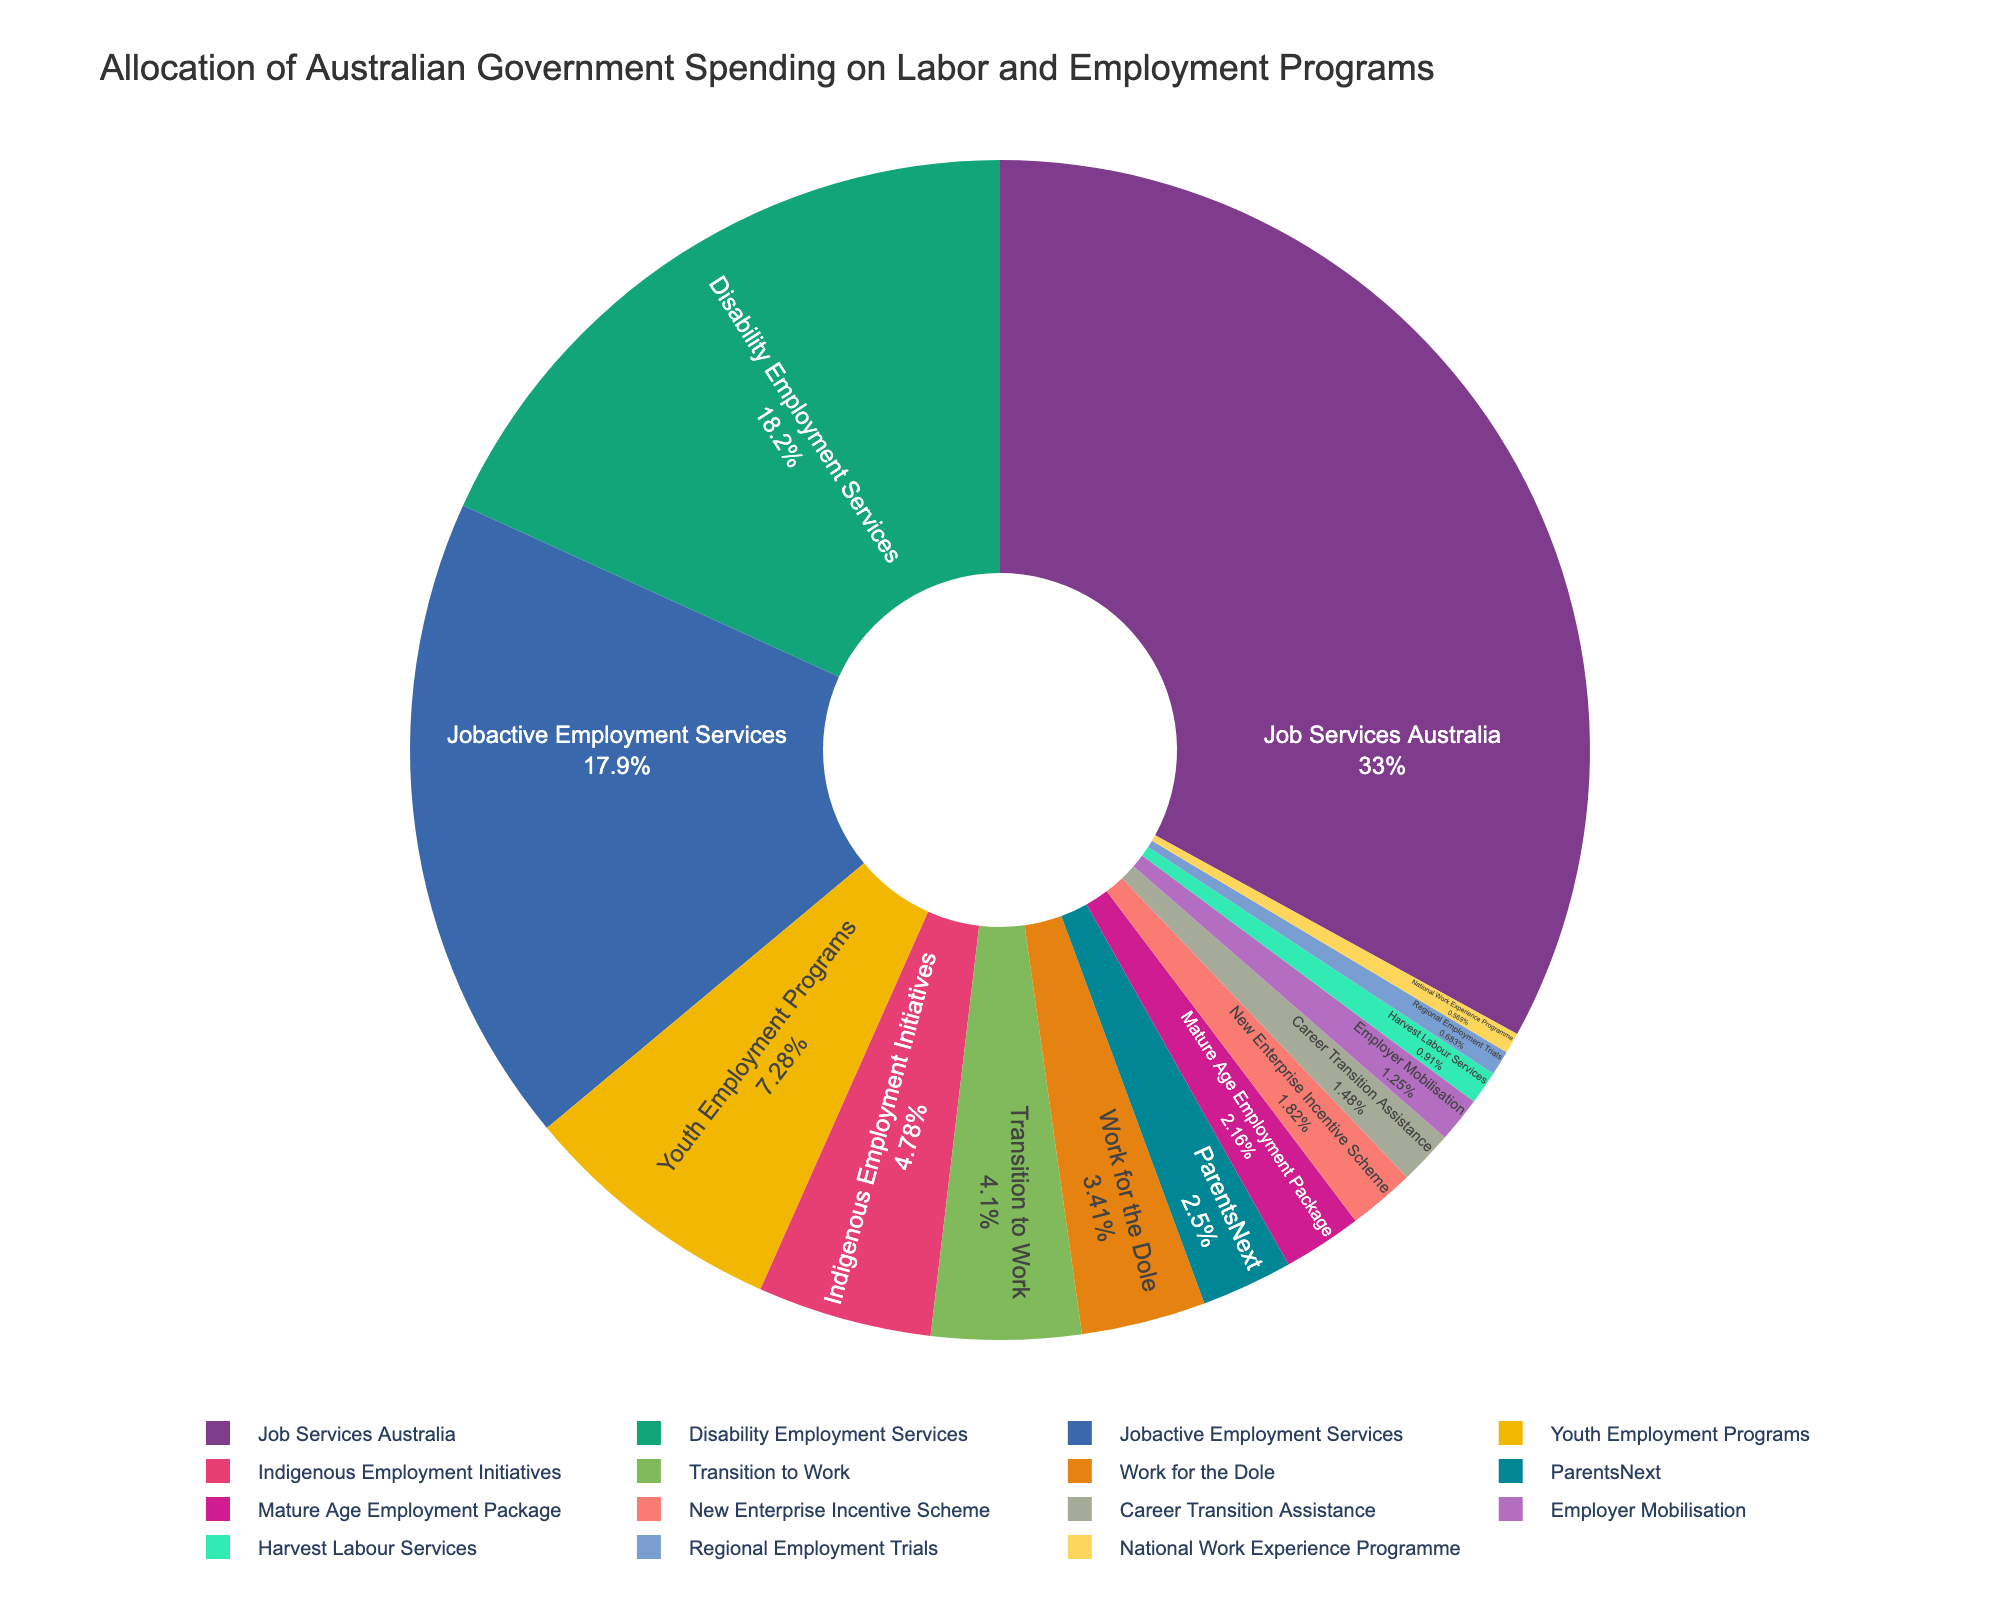What's the total spending allocated to Job Services Australia and Jobactive Employment Services? To find the total spending, sum up the allocated amounts for Job Services Australia ($1450 million) and Jobactive Employment Services ($785 million). Thus, the total spending is 1450 + 785 = 2235 million AUD.
Answer: 2235 million AUD Which category receives more funding, Disability Employment Services or Youth Employment Programs? Compare the spending amounts for Disability Employment Services ($800 million) and Youth Employment Programs ($320 million). Disability Employment Services receives more funding.
Answer: Disability Employment Services What percentage of the total budget is allocated to Indigenous Employment Initiatives and ParentsNext combined? First, sum the spending for Indigenous Employment Initiatives ($210 million) and ParentsNext ($110 million), which equals 320 million AUD. Then, to find the percentage, divide this sum by the total spending and multiply by 100. Total spending is the sum of all categories, which is 4425 million AUD. The percentage is \( \frac{320}{4425} \times 100 \approx 7.23\% \).
Answer: 7.23% Which employment program has the third highest allocation of funding? Order the categories by their funding from highest to lowest: Job Services Australia ($1450 million), Disability Employment Services ($800 million), and Jobactive Employment Services ($785 million). Thus, Jobactive Employment Services is the third highest.
Answer: Jobactive Employment Services What is the difference in funding between the highest and lowest funded programs? Identify the highest funded program (Job Services Australia at $1450 million) and the lowest funded program (National Work Experience Programme at $25 million). The difference is 1450 - 25 = 1425 million AUD.
Answer: 1425 million AUD Are any two categories funded equally? Examine the spending amounts for each category: only unique values are found, so no two categories are funded equally.
Answer: No What is the smallest allocation larger than $100 million? List all categories with more than $100 million funding: Job Services Australia ($1450 million), Jobactive Employment Services ($785 million), Disability Employment Services ($800 million), Youth Employment Programs ($320 million), Indigenous Employment Initiatives ($210 million), Work for the Dole ($150 million), Transition to Work ($180 million), Employer Mobilisation ($55 million), and Mature Age Employment Package ($95 million). The smallest of these is ParentsNext at $110 million.
Answer: ParentsNext Which category is represented with the second smallest section in the pie chart? Order the categories by their funding, and select the second smallest: National Work Experience Programme ($25 million) and Harvest Labour Services ($40 million). Thus, Harvest Labour Services is the second smallest.
Answer: Harvest Labour Services 